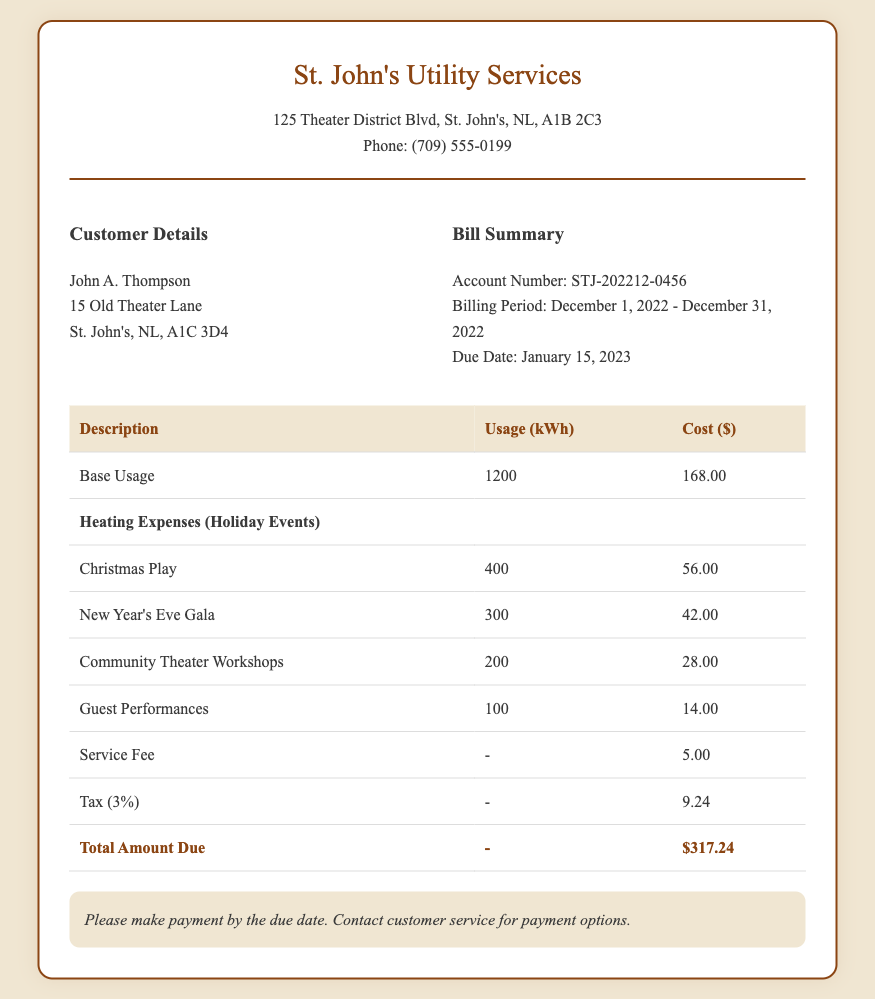what is the account number? The account number is listed in the bill summary section and is used for identifying the customer's account.
Answer: STJ-202212-0456 what is the due date for this bill? The due date is mentioned clearly in the bill summary section, indicating when the payment should be made.
Answer: January 15, 2023 how much was spent on heating expenses for the Christmas Play? The cost for heating expenses during the Christmas Play is detailed in the heating expenses section of the table.
Answer: 56.00 what is the total amount due for the bill? The total amount due is shown at the bottom of the table and represents the final amount the customer has to pay.
Answer: $317.24 how much usage was recorded for the New Year's Eve Gala? The usage for the New Year's Eve Gala is specified in the heating expenses section and indicates how much electricity was consumed.
Answer: 300 how much was the service fee? The service fee is listed in the table as part of the breakdown of costs associated with the bill.
Answer: 5.00 what was the tax percentage applied to the bill? The tax percentage is indicated in the document as part of the calculations for the total amount due.
Answer: 3% how many kWh were used for community theater workshops? The number of kWh used for community theater workshops is provided in the detailed breakdown of heating expenses.
Answer: 200 who is the customer for this utility bill? The customer name and address are specified in the customer details section of the bill.
Answer: John A. Thompson 